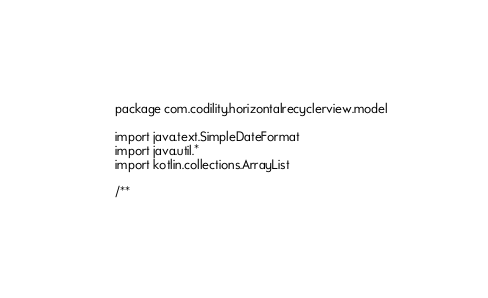<code> <loc_0><loc_0><loc_500><loc_500><_Kotlin_>package com.codility.horizontalrecyclerview.model

import java.text.SimpleDateFormat
import java.util.*
import kotlin.collections.ArrayList

/**</code> 